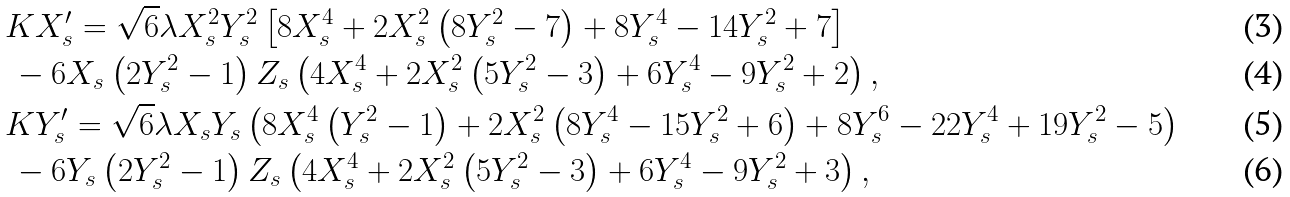<formula> <loc_0><loc_0><loc_500><loc_500>& K X _ { s } ^ { \prime } = \sqrt { 6 } \lambda X _ { s } ^ { 2 } Y _ { s } ^ { 2 } \left [ 8 X _ { s } ^ { 4 } + 2 X _ { s } ^ { 2 } \left ( 8 Y _ { s } ^ { 2 } - 7 \right ) + 8 Y _ { s } ^ { 4 } - 1 4 Y _ { s } ^ { 2 } + 7 \right ] \\ & \, - 6 X _ { s } \left ( 2 Y _ { s } ^ { 2 } - 1 \right ) Z _ { s } \left ( 4 X _ { s } ^ { 4 } + 2 X _ { s } ^ { 2 } \left ( 5 Y _ { s } ^ { 2 } - 3 \right ) + 6 Y _ { s } ^ { 4 } - 9 Y _ { s } ^ { 2 } + 2 \right ) , \\ & K Y _ { s } ^ { \prime } = \sqrt { 6 } \lambda X _ { s } Y _ { s } \left ( 8 X _ { s } ^ { 4 } \left ( Y _ { s } ^ { 2 } - 1 \right ) + 2 X _ { s } ^ { 2 } \left ( 8 Y _ { s } ^ { 4 } - 1 5 Y _ { s } ^ { 2 } + 6 \right ) + 8 Y _ { s } ^ { 6 } - 2 2 Y _ { s } ^ { 4 } + 1 9 Y _ { s } ^ { 2 } - 5 \right ) \\ & \, - 6 Y _ { s } \left ( 2 Y _ { s } ^ { 2 } - 1 \right ) Z _ { s } \left ( 4 X _ { s } ^ { 4 } + 2 X _ { s } ^ { 2 } \left ( 5 Y _ { s } ^ { 2 } - 3 \right ) + 6 Y _ { s } ^ { 4 } - 9 Y _ { s } ^ { 2 } + 3 \right ) ,</formula> 